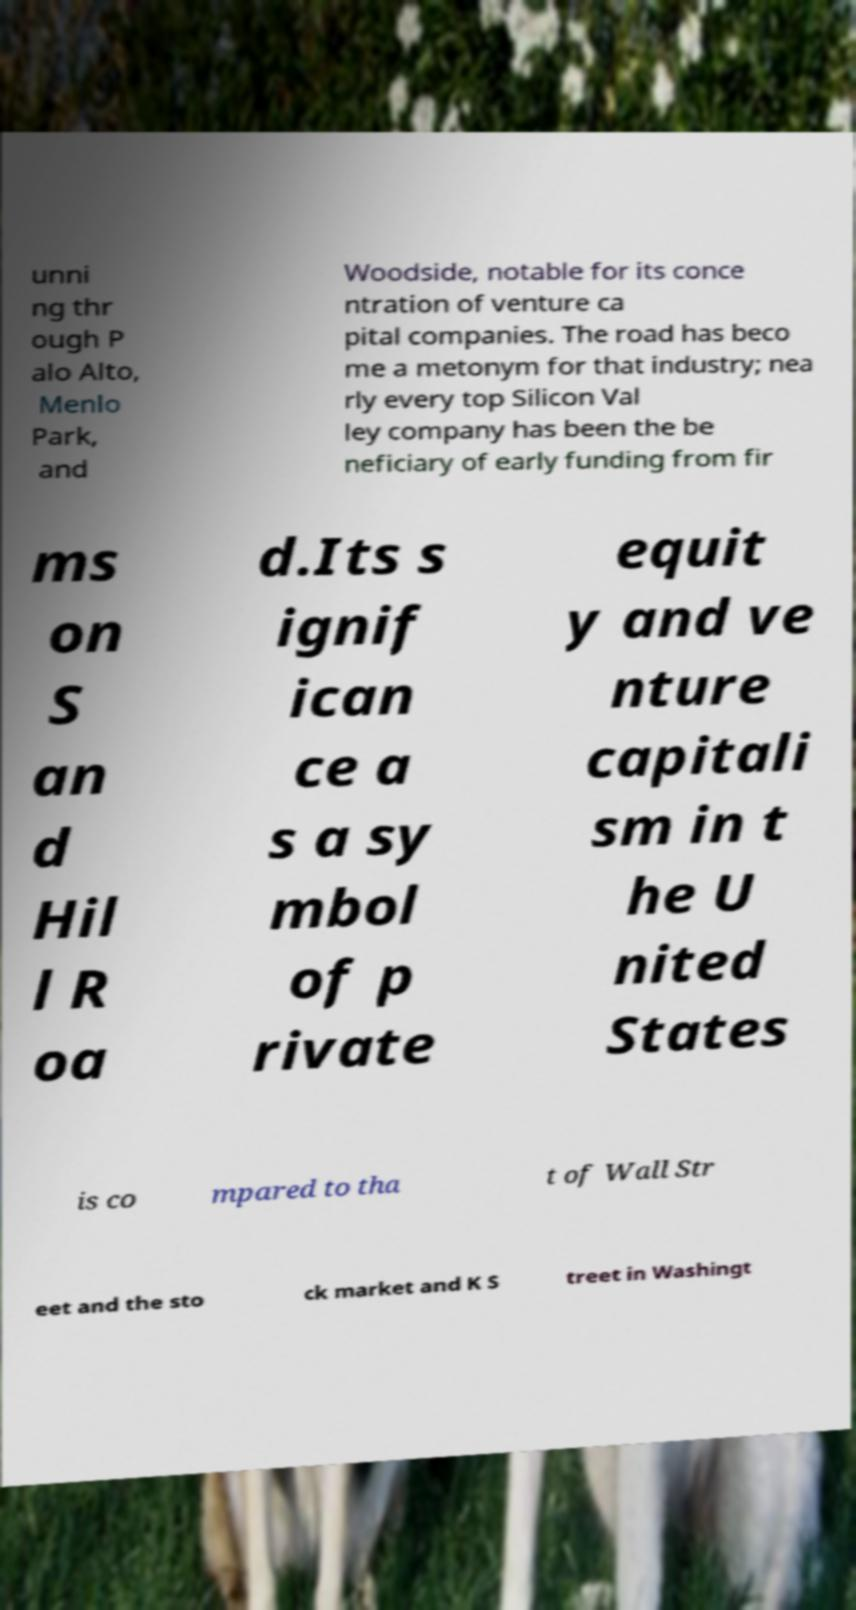For documentation purposes, I need the text within this image transcribed. Could you provide that? unni ng thr ough P alo Alto, Menlo Park, and Woodside, notable for its conce ntration of venture ca pital companies. The road has beco me a metonym for that industry; nea rly every top Silicon Val ley company has been the be neficiary of early funding from fir ms on S an d Hil l R oa d.Its s ignif ican ce a s a sy mbol of p rivate equit y and ve nture capitali sm in t he U nited States is co mpared to tha t of Wall Str eet and the sto ck market and K S treet in Washingt 